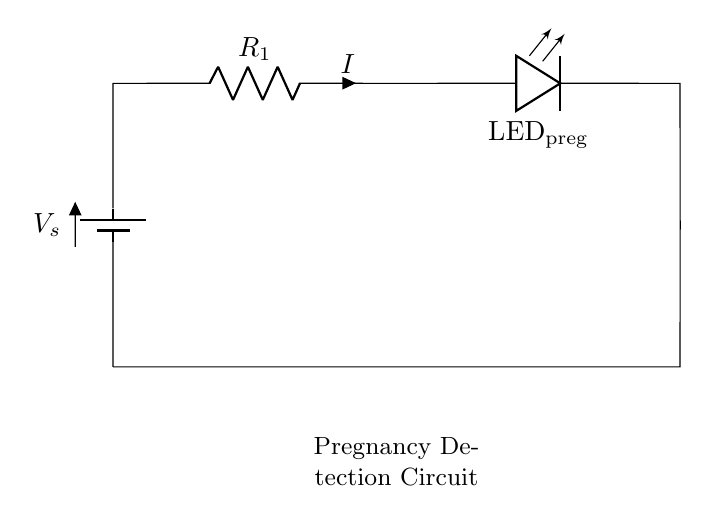What type of circuit is shown in the diagram? The diagram shows a series circuit, where components are connected end-to-end in a single path for current flow.
Answer: series circuit What does LED represent in this circuit? The LED, labeled as "LED_preg," serves as an indicator that lights up when current flows through, signaling pregnancy detection.
Answer: indicator What is the role of the resistor in this circuit? The resistor, labeled as "R_1," limits the current flowing through the LED to prevent it from burning out.
Answer: current limiting What is the direction of current flow in the circuit? The current flows from the positive terminal of the battery, through the resistor and LED, then returns to the negative terminal of the battery.
Answer: clockwise If the resistance is increased, what effect does it have on the current in this circuit? According to Ohm's law, if resistance increases while voltage remains constant, the current decreases, leading to a dimmer LED.
Answer: decrease What is the purpose of the battery labeled V_s in this circuit? The battery provides the necessary voltage to drive current through the circuit components, allowing the LED to illuminate when activated.
Answer: power source 